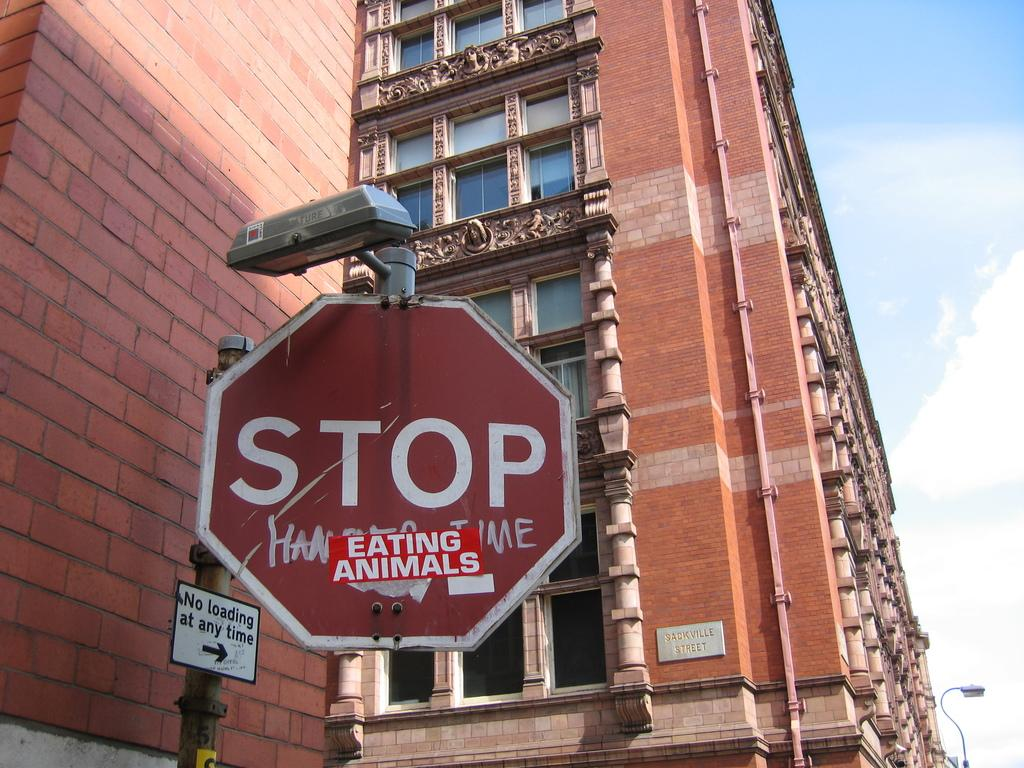Provide a one-sentence caption for the provided image. A big building with a stop sign that has a sticker saying eating animals. 